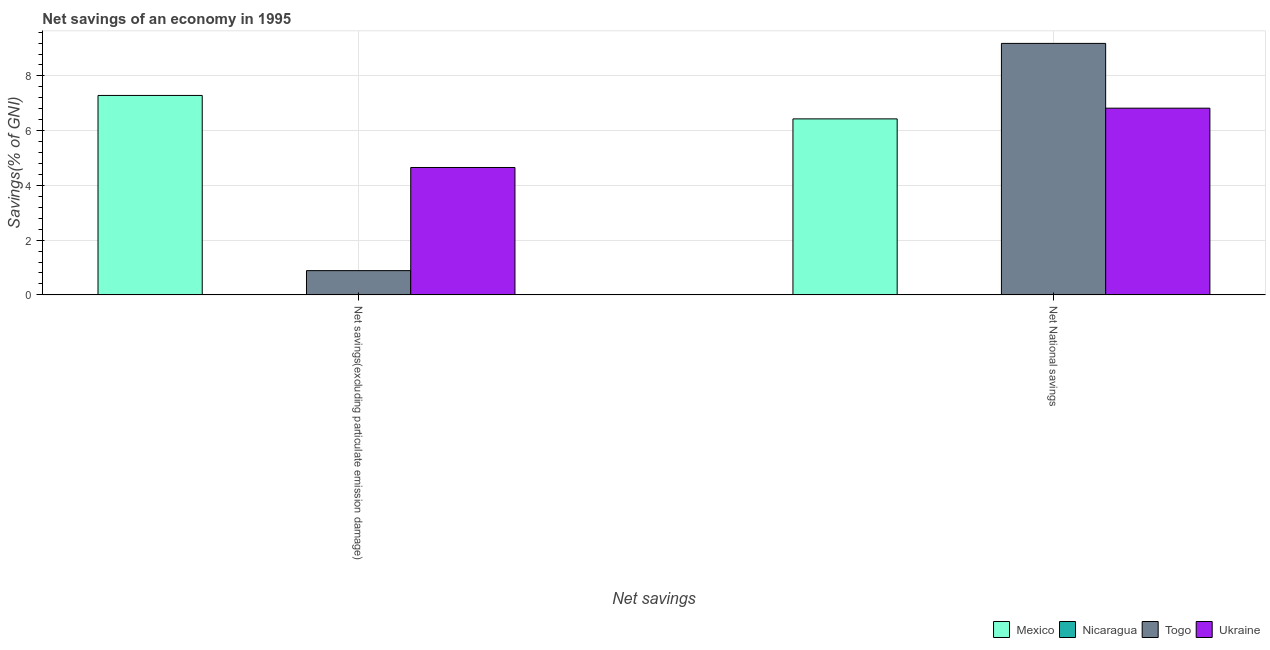How many groups of bars are there?
Give a very brief answer. 2. Are the number of bars per tick equal to the number of legend labels?
Make the answer very short. No. What is the label of the 1st group of bars from the left?
Your answer should be compact. Net savings(excluding particulate emission damage). What is the net savings(excluding particulate emission damage) in Ukraine?
Make the answer very short. 4.65. Across all countries, what is the maximum net national savings?
Your answer should be very brief. 9.19. Across all countries, what is the minimum net national savings?
Ensure brevity in your answer.  0. What is the total net savings(excluding particulate emission damage) in the graph?
Make the answer very short. 12.83. What is the difference between the net savings(excluding particulate emission damage) in Togo and that in Mexico?
Offer a terse response. -6.4. What is the difference between the net national savings in Togo and the net savings(excluding particulate emission damage) in Ukraine?
Provide a succinct answer. 4.53. What is the average net national savings per country?
Your response must be concise. 5.61. What is the difference between the net national savings and net savings(excluding particulate emission damage) in Togo?
Keep it short and to the point. 8.3. In how many countries, is the net savings(excluding particulate emission damage) greater than 0.4 %?
Ensure brevity in your answer.  3. What is the ratio of the net national savings in Togo to that in Mexico?
Your answer should be very brief. 1.43. In how many countries, is the net national savings greater than the average net national savings taken over all countries?
Offer a very short reply. 3. How many countries are there in the graph?
Make the answer very short. 4. Are the values on the major ticks of Y-axis written in scientific E-notation?
Provide a short and direct response. No. Does the graph contain any zero values?
Provide a succinct answer. Yes. Where does the legend appear in the graph?
Provide a short and direct response. Bottom right. How many legend labels are there?
Offer a very short reply. 4. How are the legend labels stacked?
Provide a short and direct response. Horizontal. What is the title of the graph?
Keep it short and to the point. Net savings of an economy in 1995. What is the label or title of the X-axis?
Your answer should be very brief. Net savings. What is the label or title of the Y-axis?
Offer a very short reply. Savings(% of GNI). What is the Savings(% of GNI) in Mexico in Net savings(excluding particulate emission damage)?
Keep it short and to the point. 7.29. What is the Savings(% of GNI) of Togo in Net savings(excluding particulate emission damage)?
Your response must be concise. 0.89. What is the Savings(% of GNI) in Ukraine in Net savings(excluding particulate emission damage)?
Make the answer very short. 4.65. What is the Savings(% of GNI) of Mexico in Net National savings?
Your answer should be very brief. 6.43. What is the Savings(% of GNI) in Nicaragua in Net National savings?
Offer a terse response. 0. What is the Savings(% of GNI) of Togo in Net National savings?
Ensure brevity in your answer.  9.19. What is the Savings(% of GNI) in Ukraine in Net National savings?
Your response must be concise. 6.82. Across all Net savings, what is the maximum Savings(% of GNI) in Mexico?
Your answer should be very brief. 7.29. Across all Net savings, what is the maximum Savings(% of GNI) of Togo?
Your response must be concise. 9.19. Across all Net savings, what is the maximum Savings(% of GNI) of Ukraine?
Your answer should be compact. 6.82. Across all Net savings, what is the minimum Savings(% of GNI) of Mexico?
Make the answer very short. 6.43. Across all Net savings, what is the minimum Savings(% of GNI) of Togo?
Provide a succinct answer. 0.89. Across all Net savings, what is the minimum Savings(% of GNI) in Ukraine?
Give a very brief answer. 4.65. What is the total Savings(% of GNI) of Mexico in the graph?
Offer a terse response. 13.72. What is the total Savings(% of GNI) of Togo in the graph?
Provide a short and direct response. 10.08. What is the total Savings(% of GNI) in Ukraine in the graph?
Your answer should be very brief. 11.48. What is the difference between the Savings(% of GNI) of Mexico in Net savings(excluding particulate emission damage) and that in Net National savings?
Your answer should be very brief. 0.86. What is the difference between the Savings(% of GNI) in Togo in Net savings(excluding particulate emission damage) and that in Net National savings?
Offer a terse response. -8.3. What is the difference between the Savings(% of GNI) of Ukraine in Net savings(excluding particulate emission damage) and that in Net National savings?
Offer a very short reply. -2.17. What is the difference between the Savings(% of GNI) in Mexico in Net savings(excluding particulate emission damage) and the Savings(% of GNI) in Togo in Net National savings?
Keep it short and to the point. -1.9. What is the difference between the Savings(% of GNI) in Mexico in Net savings(excluding particulate emission damage) and the Savings(% of GNI) in Ukraine in Net National savings?
Provide a short and direct response. 0.47. What is the difference between the Savings(% of GNI) of Togo in Net savings(excluding particulate emission damage) and the Savings(% of GNI) of Ukraine in Net National savings?
Offer a very short reply. -5.94. What is the average Savings(% of GNI) of Mexico per Net savings?
Your answer should be compact. 6.86. What is the average Savings(% of GNI) of Togo per Net savings?
Offer a terse response. 5.04. What is the average Savings(% of GNI) of Ukraine per Net savings?
Make the answer very short. 5.74. What is the difference between the Savings(% of GNI) of Mexico and Savings(% of GNI) of Togo in Net savings(excluding particulate emission damage)?
Provide a short and direct response. 6.4. What is the difference between the Savings(% of GNI) in Mexico and Savings(% of GNI) in Ukraine in Net savings(excluding particulate emission damage)?
Your answer should be very brief. 2.63. What is the difference between the Savings(% of GNI) in Togo and Savings(% of GNI) in Ukraine in Net savings(excluding particulate emission damage)?
Make the answer very short. -3.77. What is the difference between the Savings(% of GNI) of Mexico and Savings(% of GNI) of Togo in Net National savings?
Your answer should be compact. -2.76. What is the difference between the Savings(% of GNI) in Mexico and Savings(% of GNI) in Ukraine in Net National savings?
Provide a short and direct response. -0.39. What is the difference between the Savings(% of GNI) of Togo and Savings(% of GNI) of Ukraine in Net National savings?
Your response must be concise. 2.37. What is the ratio of the Savings(% of GNI) of Mexico in Net savings(excluding particulate emission damage) to that in Net National savings?
Make the answer very short. 1.13. What is the ratio of the Savings(% of GNI) in Togo in Net savings(excluding particulate emission damage) to that in Net National savings?
Make the answer very short. 0.1. What is the ratio of the Savings(% of GNI) in Ukraine in Net savings(excluding particulate emission damage) to that in Net National savings?
Your response must be concise. 0.68. What is the difference between the highest and the second highest Savings(% of GNI) in Mexico?
Keep it short and to the point. 0.86. What is the difference between the highest and the second highest Savings(% of GNI) of Togo?
Provide a succinct answer. 8.3. What is the difference between the highest and the second highest Savings(% of GNI) in Ukraine?
Offer a terse response. 2.17. What is the difference between the highest and the lowest Savings(% of GNI) in Mexico?
Provide a short and direct response. 0.86. What is the difference between the highest and the lowest Savings(% of GNI) in Togo?
Your response must be concise. 8.3. What is the difference between the highest and the lowest Savings(% of GNI) of Ukraine?
Keep it short and to the point. 2.17. 